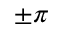<formula> <loc_0><loc_0><loc_500><loc_500>\pm \pi</formula> 